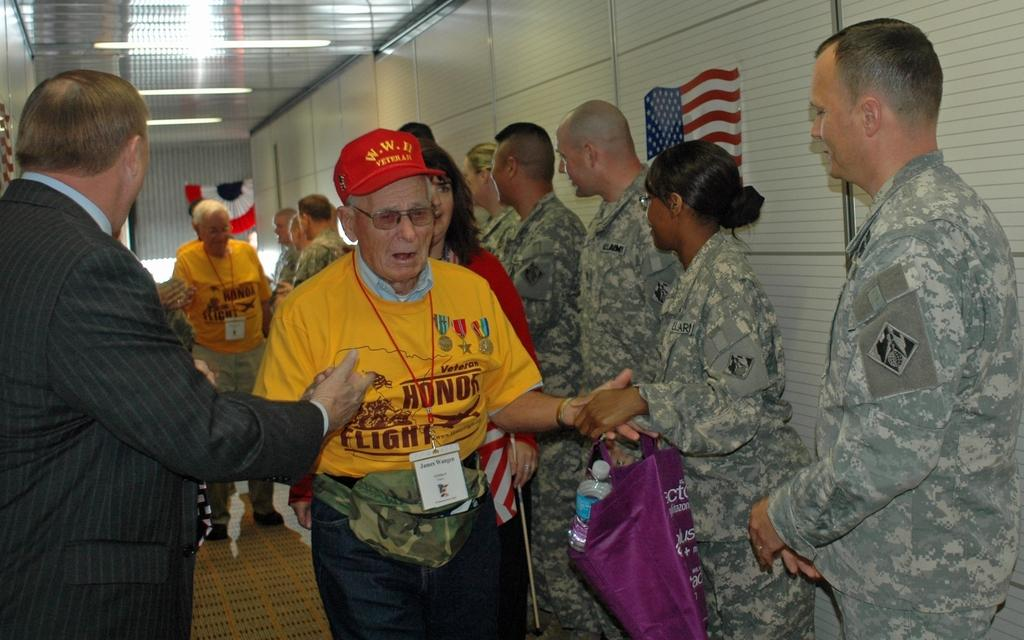Who is present in the image? There are people in the image. What type of people can be seen in the image? There are soldiers in the image. Where is the flag located in the image? The flag is on the right side of the wall in the image. What can be seen near the ceiling in the image? There are lights near the ceiling in the image. What type of behavior can be seen in the bushes in the image? There are no bushes present in the image, so it is not possible to observe any behavior in them. 